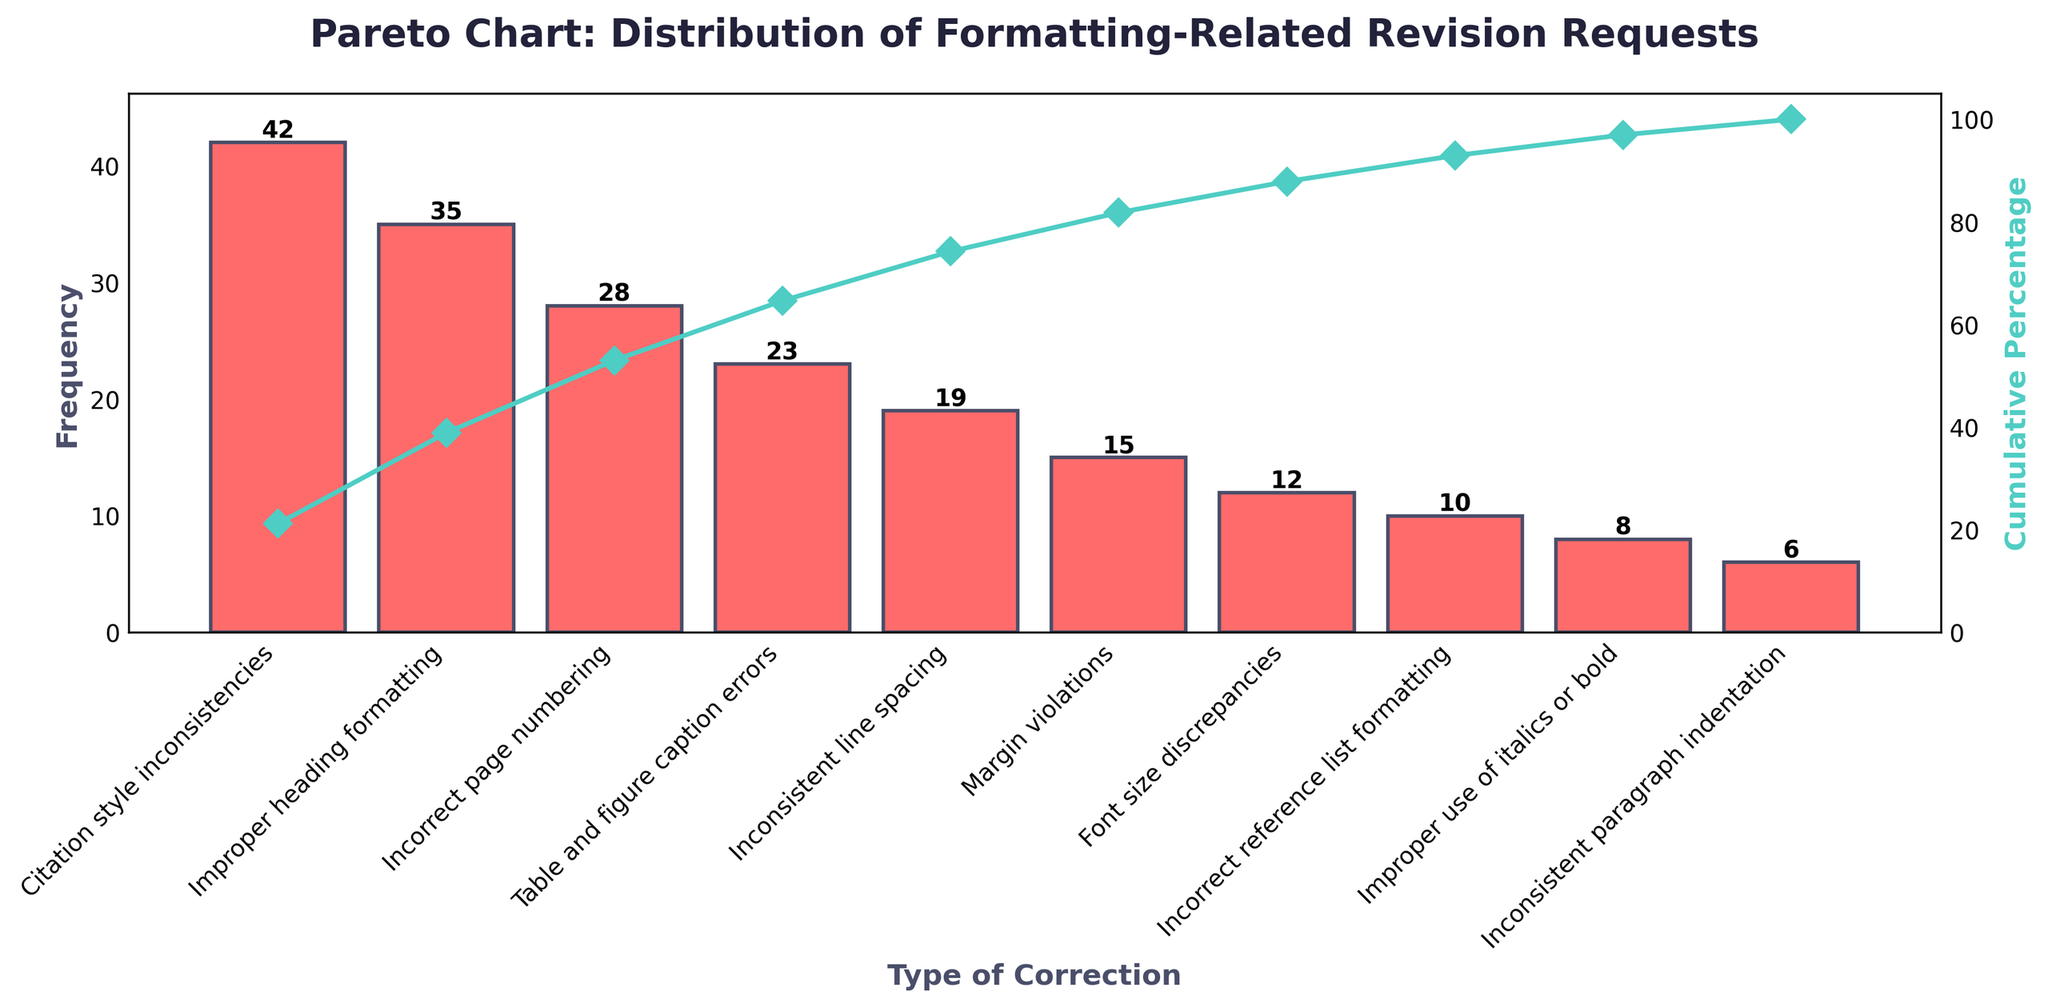What is the title of the chart? The title of the chart is typically found at the top and usually in a larger, bold font. Here it reads "Pareto Chart: Distribution of Formatting-Related Revision Requests".
Answer: Pareto Chart: Distribution of Formatting-Related Revision Requests Which type of correction has the highest frequency of revisions? By examining the lengths of the bars, the longest bar corresponds to 'Citation style inconsistencies' with a frequency of 42.
Answer: Citation style inconsistencies What is the cumulative percentage for "Improper heading formatting"? The cumulative percentage line shows the cumulative impact of each bar. For "Improper heading formatting" at its position on the x-axis, the exact value from the chart is necessary for precision.
Answer: Check the figure How many types of corrections have a cumulative percentage under 50%? To determine how many categories contribute to less than 50% of cumulative percentage, check the line plot until it crosses the 50% mark.
Answer: 2 What is the combined frequency of the three most common types of corrections? Adding up the frequencies of the top three, which are (42 + 35 + 28).
Answer: 105 Which types of corrections have a frequency lower than 10? By examining the bars with heights less than 10 units and reading their labels, they are "Improper use of italics or bold" and "Inconsistent paragraph indentation".
Answer: Improper use of italics or bold, Inconsistent paragraph indentation How much higher is the frequency of 'Incorrect page numbering' compared to 'Font size discrepancies'? This question requires subtraction of the latter frequency from the former: (28 - 12).
Answer: 16 Considering both axes, which type of correction contributes most to the initial steep rise in cumulative percentage? The initial steep rise is mainly due to the first few bars, particularly the first one, 'Citation style inconsistencies', as it sets off the highest initial increase.
Answer: Citation style inconsistencies If I want to address the majority (over 75%) of the formatting issues, which categories should I focus on? To cover over 75% of issues, look at the cumulative percentage line until it surpasses 75%, which includes the first seven types.
Answer: Citation style inconsistencies, Improper heading formatting, Incorrect page numbering, Table and figure caption errors, Inconsistent line spacing, Margin violations, Font size discrepancies 